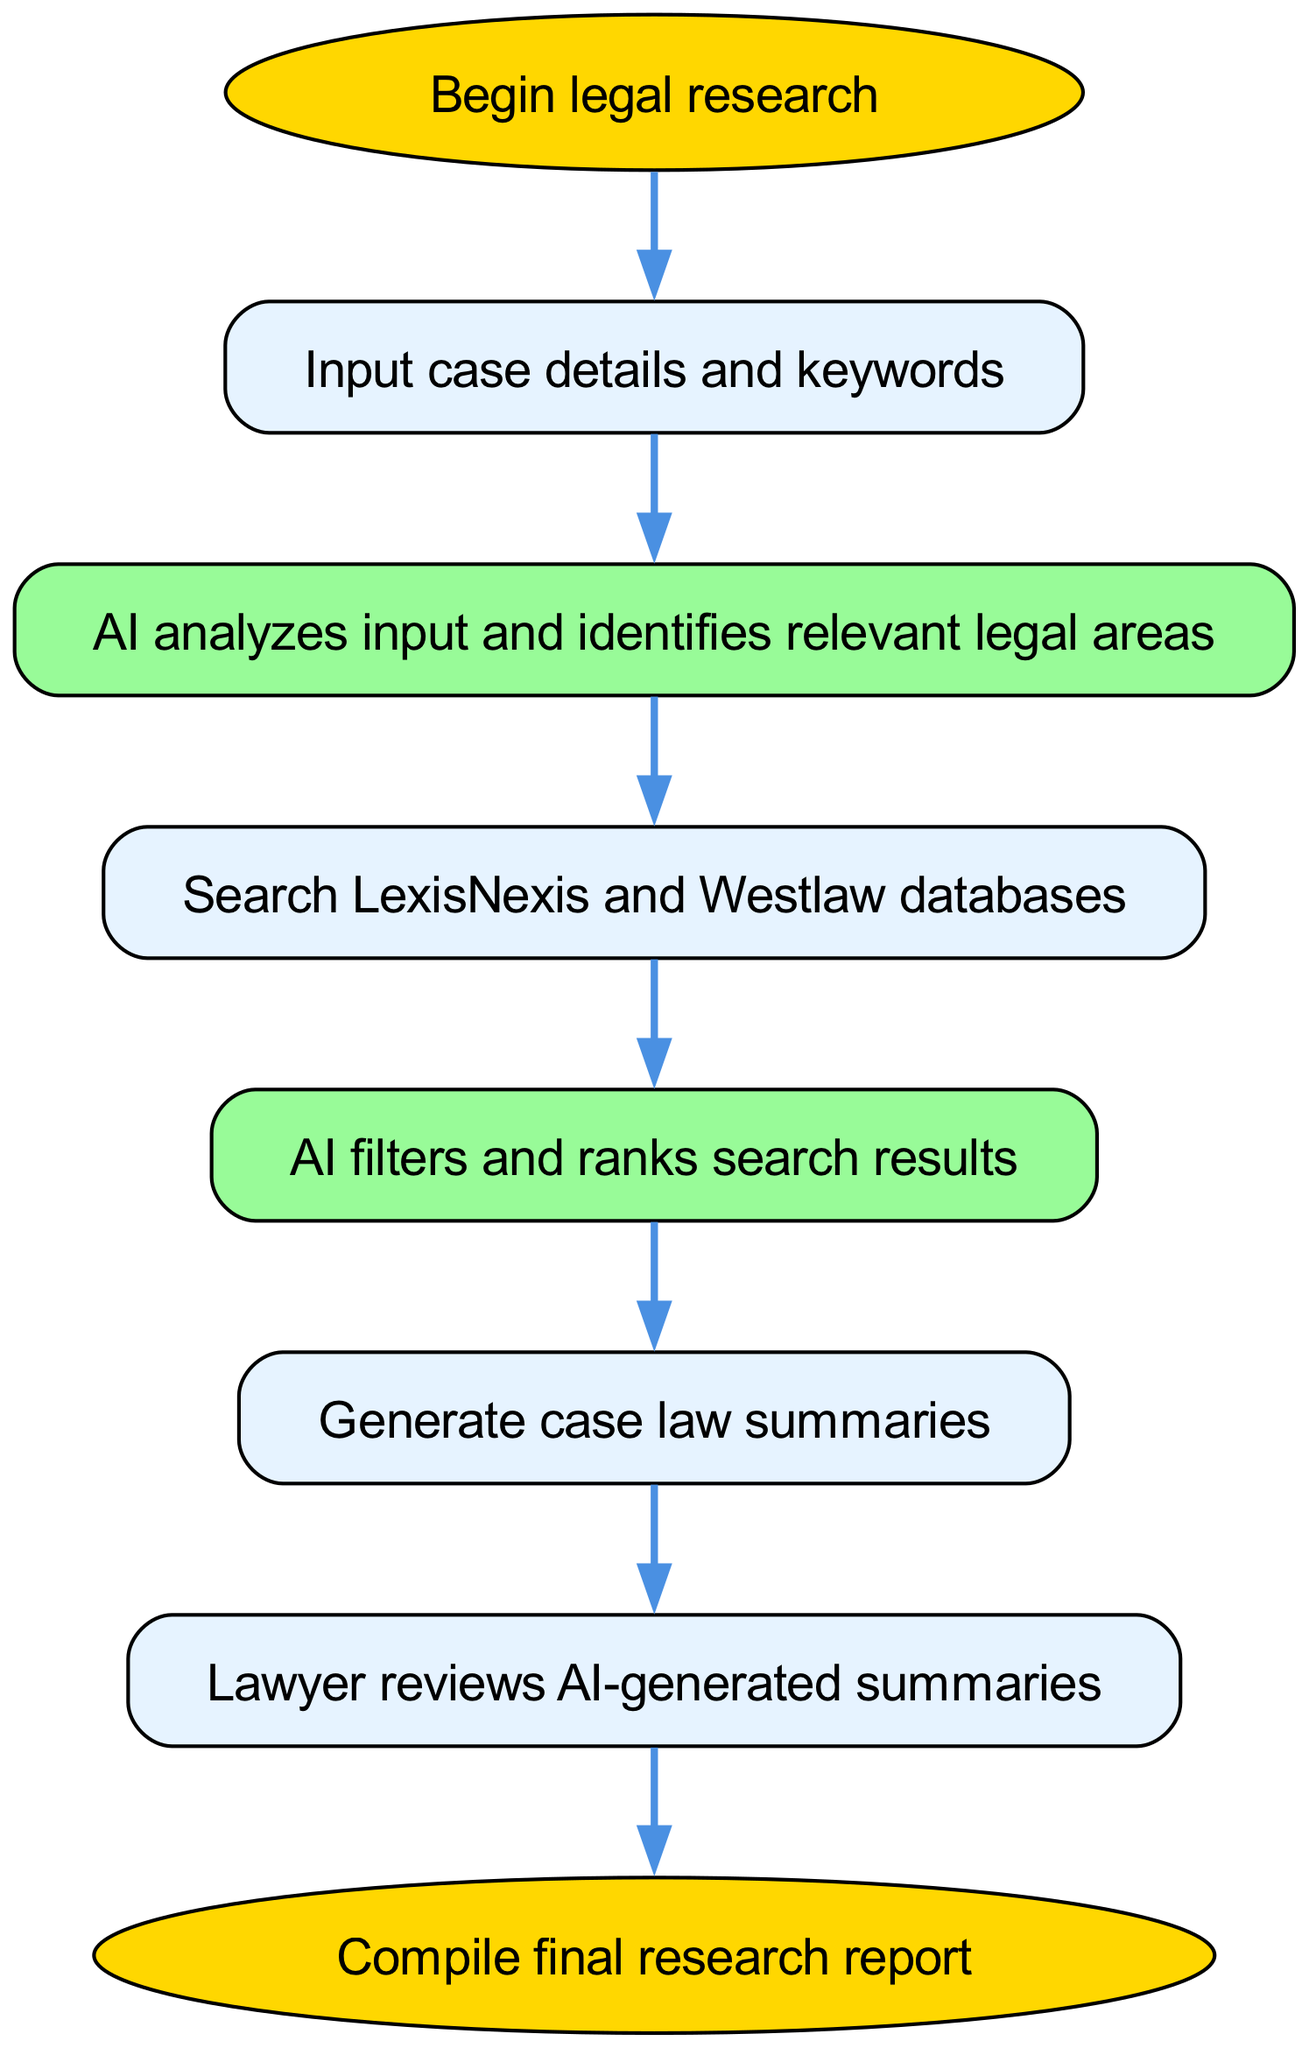What is the starting point of the flowchart? The starting point is identified by the node labeled "Begin legal research." It is the first node in the diagram from which the process initiates.
Answer: Begin legal research How many nodes are there in total? To find the total number of nodes, we can count each unique node in the provided data. There are 8 distinct nodes.
Answer: 8 What is the first action taken after inputting case details? The flowchart shows that after entering the details and keywords, the next action is performed by the AI as it analyzes the input and identifies relevant legal areas.
Answer: AI analyzes input and identifies relevant legal areas Which database is searched after AI analysis? The diagram specifies that LexisNexis and Westlaw databases are searched following the AI analysis step.
Answer: LexisNexis and Westlaw What are the two steps immediately before the final report compilation? The steps preceding the final report compilation are the lawyer reviewing the AI-generated summaries, followed by the generation of case law summaries. Both are connected before reaching the endpoint.
Answer: Review and Generate case law summaries What is the function of the filtering step? The filtering step's purpose is for the AI to filter and rank the search results, ensuring that the lawyer reviews the most relevant information, which enhances efficiency and accuracy in the research process.
Answer: AI filters and ranks search results Which node can be identified as an end point? The end point can be identified by the node labeled "Compile final research report," clearly indicated as the conclusion of the process flow within the diagram.
Answer: Compile final research report How do the AI analysis and database search stages connect? The connection between the AI analysis and database search stages is directional; once the AI identifies relevant areas, the subsequent action is to initiate a search in the specified legal databases. This establishes a flow from analysis to search.
Answer: AI analyzes input and identifies relevant legal areas to Search LexisNexis and Westlaw databases 